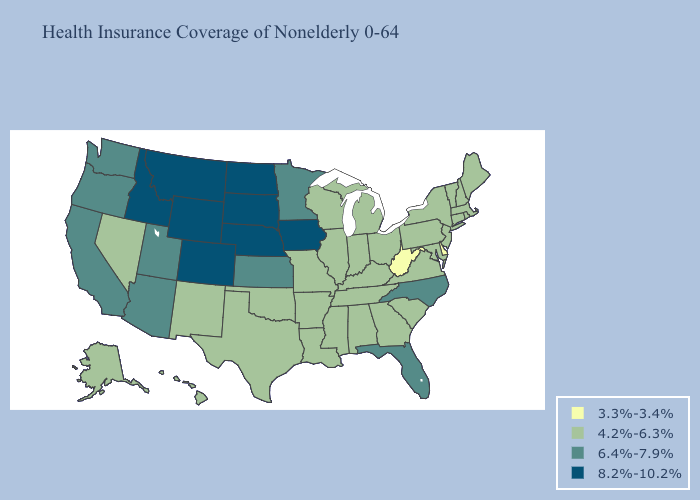Name the states that have a value in the range 6.4%-7.9%?
Write a very short answer. Arizona, California, Florida, Kansas, Minnesota, North Carolina, Oregon, Utah, Washington. Does Oklahoma have the lowest value in the USA?
Short answer required. No. Among the states that border Kansas , does Missouri have the highest value?
Keep it brief. No. Does the map have missing data?
Answer briefly. No. Does the first symbol in the legend represent the smallest category?
Write a very short answer. Yes. Name the states that have a value in the range 6.4%-7.9%?
Be succinct. Arizona, California, Florida, Kansas, Minnesota, North Carolina, Oregon, Utah, Washington. What is the value of Nebraska?
Keep it brief. 8.2%-10.2%. Does the map have missing data?
Write a very short answer. No. Does Oregon have a higher value than Minnesota?
Quick response, please. No. Which states have the highest value in the USA?
Concise answer only. Colorado, Idaho, Iowa, Montana, Nebraska, North Dakota, South Dakota, Wyoming. Does California have a lower value than Wyoming?
Answer briefly. Yes. Which states have the lowest value in the USA?
Answer briefly. Delaware, West Virginia. Name the states that have a value in the range 6.4%-7.9%?
Quick response, please. Arizona, California, Florida, Kansas, Minnesota, North Carolina, Oregon, Utah, Washington. Name the states that have a value in the range 4.2%-6.3%?
Quick response, please. Alabama, Alaska, Arkansas, Connecticut, Georgia, Hawaii, Illinois, Indiana, Kentucky, Louisiana, Maine, Maryland, Massachusetts, Michigan, Mississippi, Missouri, Nevada, New Hampshire, New Jersey, New Mexico, New York, Ohio, Oklahoma, Pennsylvania, Rhode Island, South Carolina, Tennessee, Texas, Vermont, Virginia, Wisconsin. Name the states that have a value in the range 3.3%-3.4%?
Be succinct. Delaware, West Virginia. 